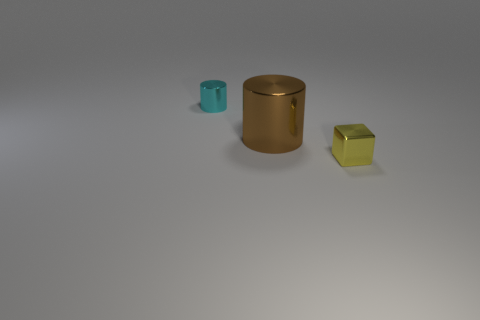Add 1 small yellow cubes. How many objects exist? 4 Subtract all blocks. How many objects are left? 2 Add 3 red matte cylinders. How many red matte cylinders exist? 3 Subtract 0 blue balls. How many objects are left? 3 Subtract all large gray rubber things. Subtract all small metallic things. How many objects are left? 1 Add 2 brown shiny things. How many brown shiny things are left? 3 